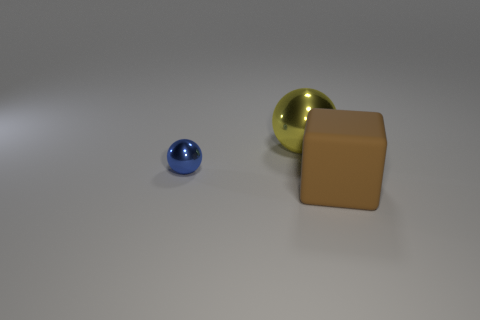Is there anything else that has the same material as the blue ball?
Your response must be concise. Yes. There is a large object in front of the yellow metallic thing; what is its shape?
Give a very brief answer. Cube. Is there a object that is behind the thing right of the large object on the left side of the brown cube?
Your answer should be compact. Yes. Is there any other thing that has the same shape as the tiny blue metal thing?
Your answer should be very brief. Yes. Is there a small gray matte block?
Offer a terse response. No. Is the material of the big object in front of the blue ball the same as the large thing that is left of the matte cube?
Provide a succinct answer. No. What is the size of the sphere right of the shiny thing that is on the left side of the large thing that is on the left side of the big brown matte block?
Provide a succinct answer. Large. How many big yellow balls are the same material as the blue sphere?
Offer a terse response. 1. Are there fewer small purple metallic cylinders than large balls?
Your response must be concise. Yes. What size is the other blue object that is the same shape as the big shiny thing?
Your answer should be very brief. Small. 